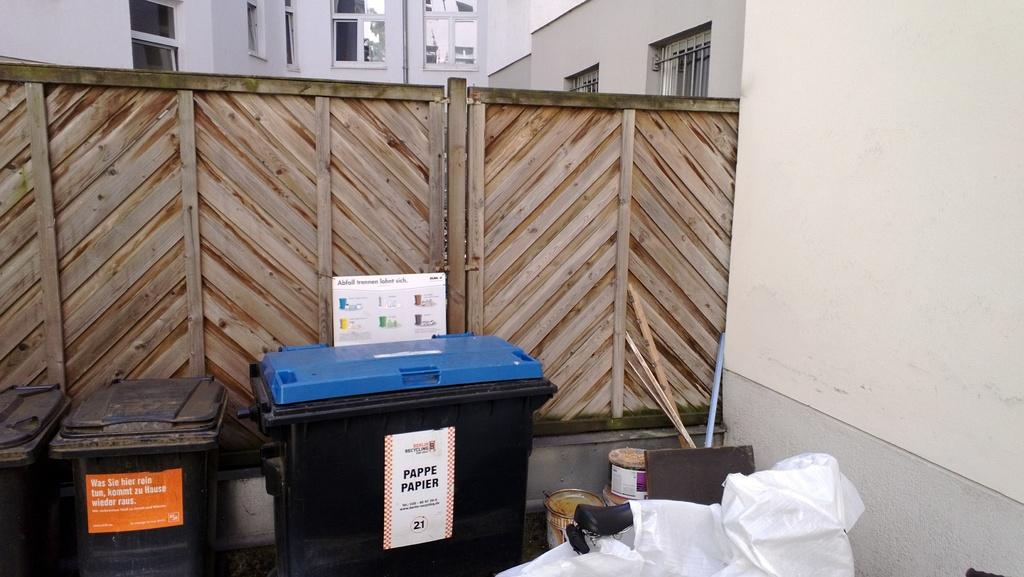<image>
Present a compact description of the photo's key features. Trashcans are lined against a wooden fence with one reading "Pappe Papier" 